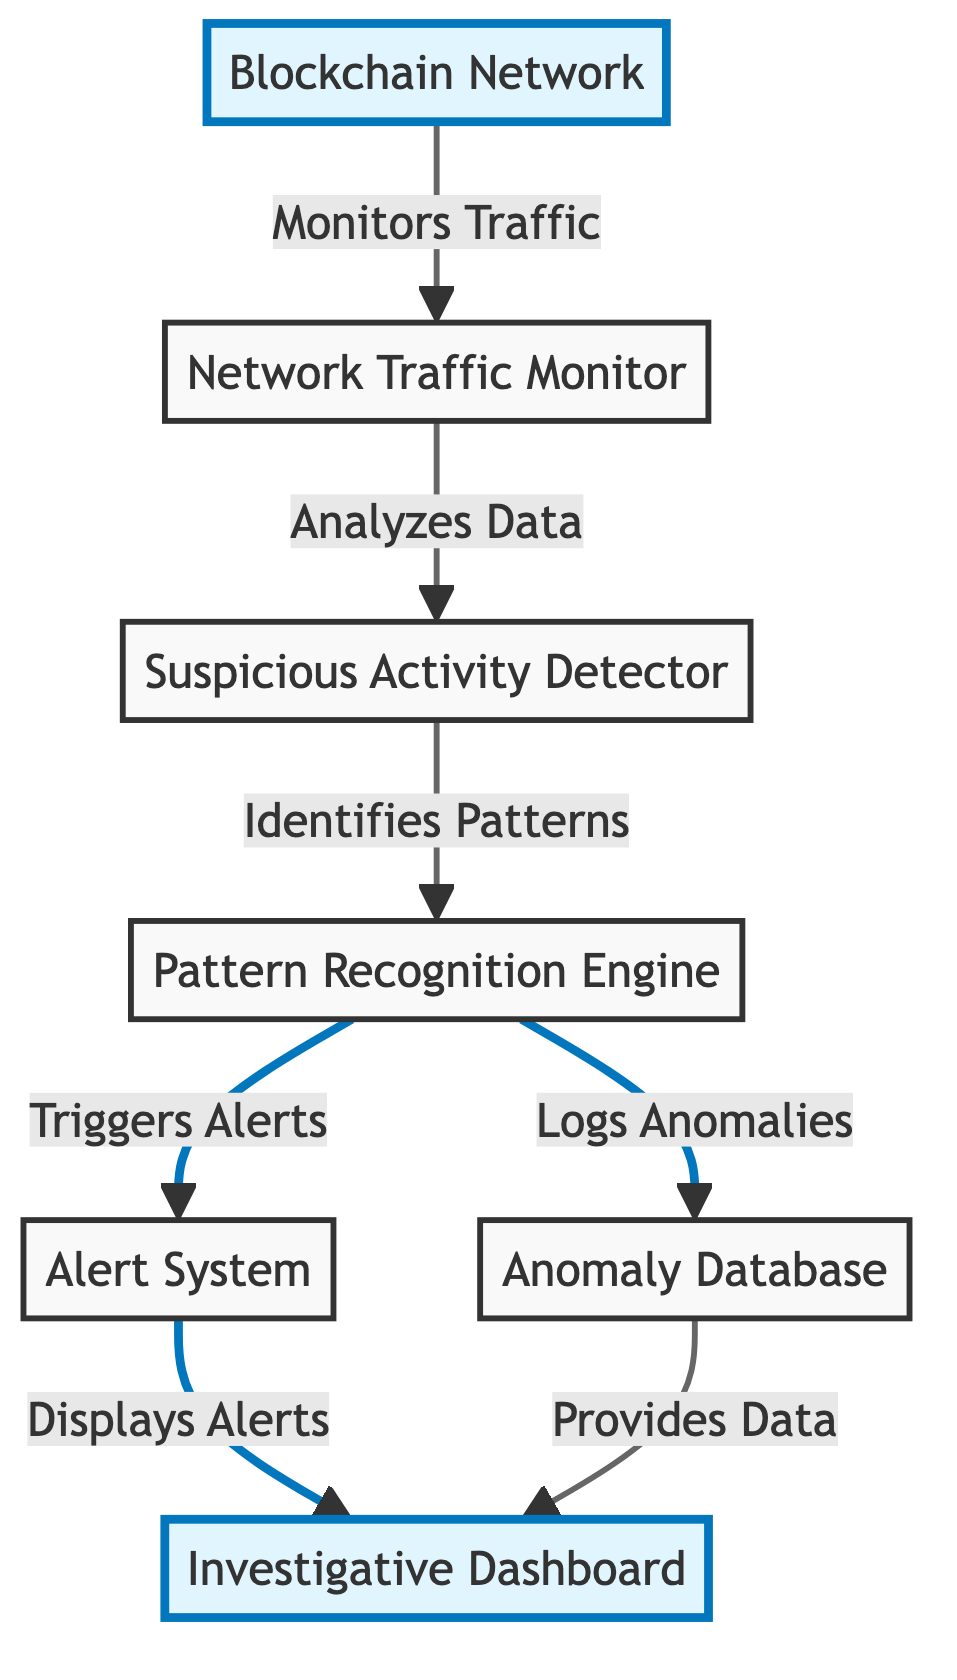What is the starting point of the flow in the diagram? The flow of the diagram starts from the node labeled "Blockchain Network", which is highlighted to indicate its significance.
Answer: Blockchain Network How many nodes are there in total? Counting all the individual elements in the diagram, there are seven distinct nodes present.
Answer: Seven What system analyzes data within the network traffic monitor? The node responsible for analyzing data is the "Suspicious Activity Detector", as indicated by the direct flow connection from the "Network Traffic Monitor" to this node.
Answer: Suspicious Activity Detector What does the Pattern Recognition Engine do? The Pattern Recognition Engine identifies patterns, logs anomalies, and triggers alerts, based on the relationships and functions connected to it in the diagram.
Answer: Identifies patterns Which node triggers alerts? According to the diagram, the "Pattern Recognition Engine" triggers alerts, which means this is the action connected to this node.
Answer: Pattern Recognition Engine How does the Investigative Dashboard receive data? The Investigative Dashboard receives data from the "Anomaly Database", which is shown to provide data to it in the relationships established in the diagram.
Answer: Anomaly Database What system displays the alerts from the alert system? The alerts from the alert system are displayed in the "Investigative Dashboard", as per the direct connection indicated in the diagram.
Answer: Investigative Dashboard Which component is responsible for logging anomalies? The "Pattern Recognition Engine" is responsible for logging anomalies, as illustrated by the outgoing link to the "Anomaly Database".
Answer: Pattern Recognition Engine What does the Network Traffic Monitor connect to? The Network Traffic Monitor connects to the "Suspicious Activity Detector", which shows the sequential flow of functions in the diagram.
Answer: Suspicious Activity Detector 